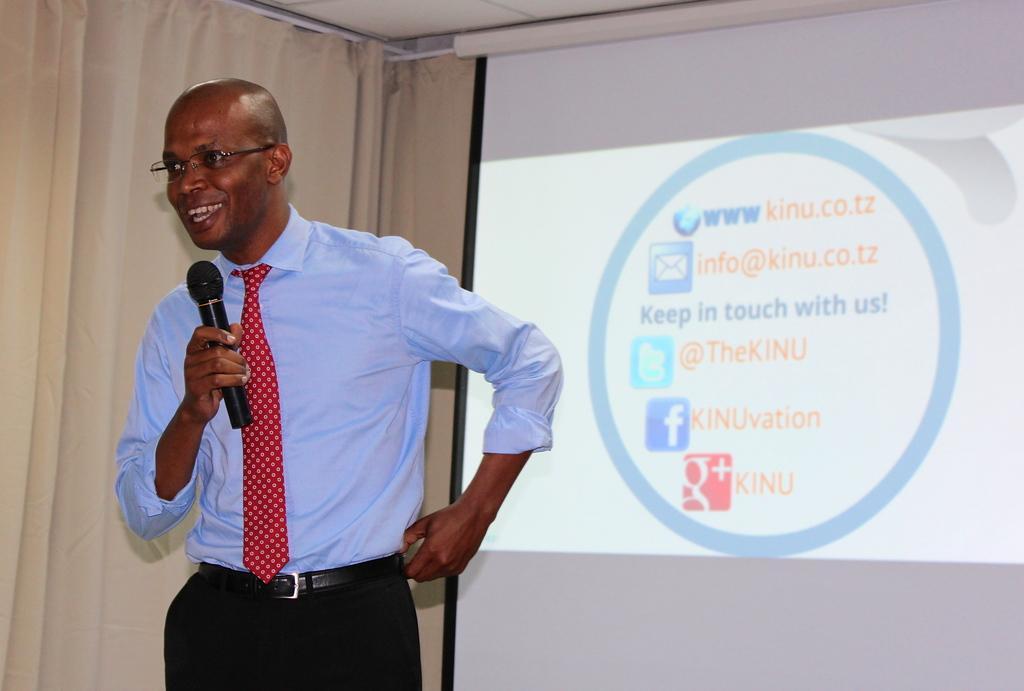Describe this image in one or two sentences. In this picture there is a person who is standing on the left side of the image, by holding a mic in his hand, there is a projector screen on the right side of the image and there is a curtain on the left side of the image. 